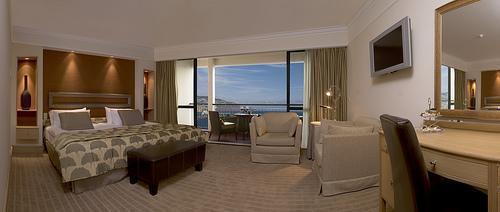How many beds are there?
Give a very brief answer. 1. How many people can be seen?
Give a very brief answer. 0. How many lights are above the bed?
Give a very brief answer. 2. How many tan chairs are there?
Give a very brief answer. 2. 